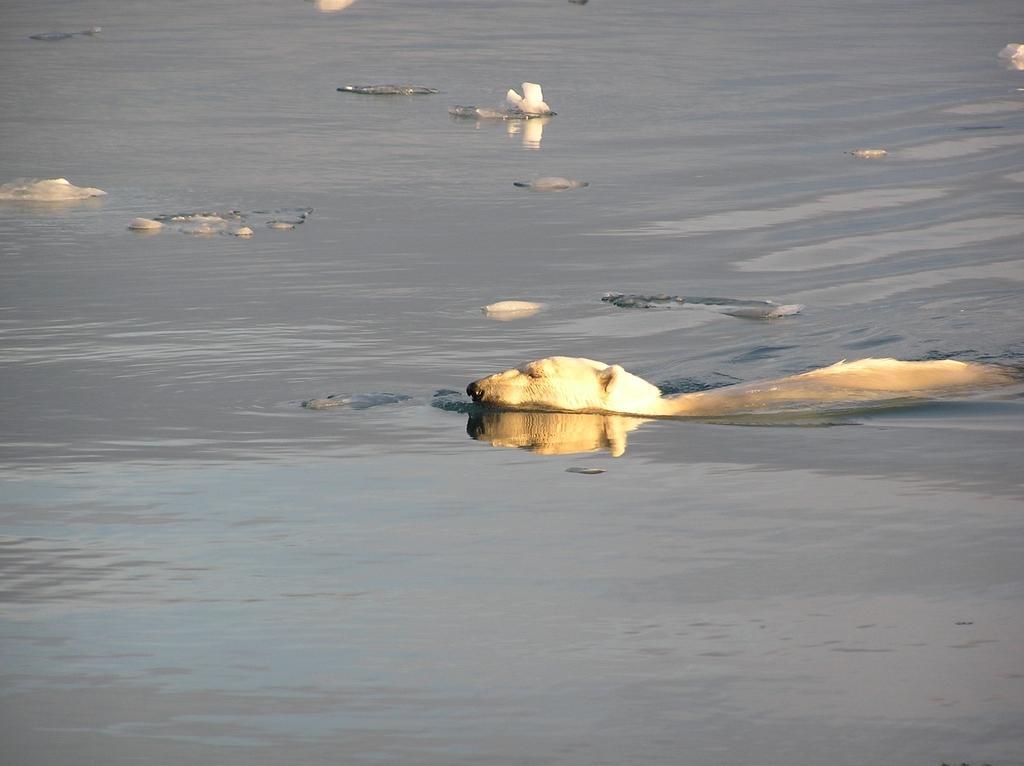Can you describe this image briefly? In this image we can see few animals in the water. 